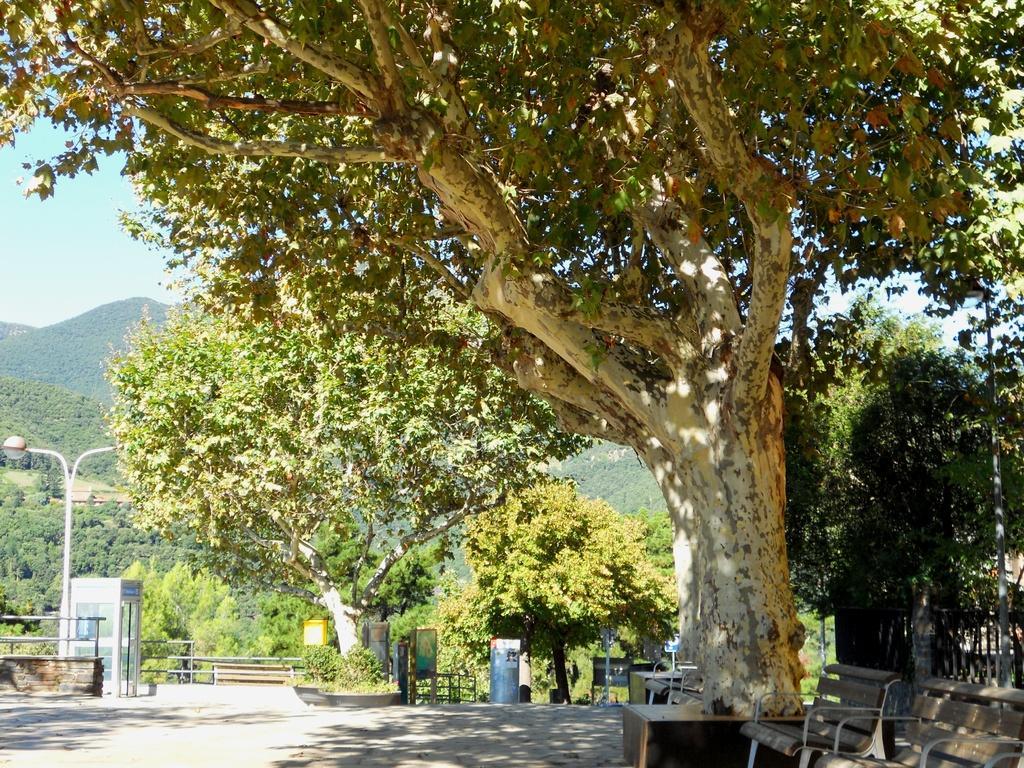In one or two sentences, can you explain what this image depicts? In the image we can see trees and the benches under the tree. Here we can see the fence, light pole, road and the board. We can even see the mountain and the sky. 